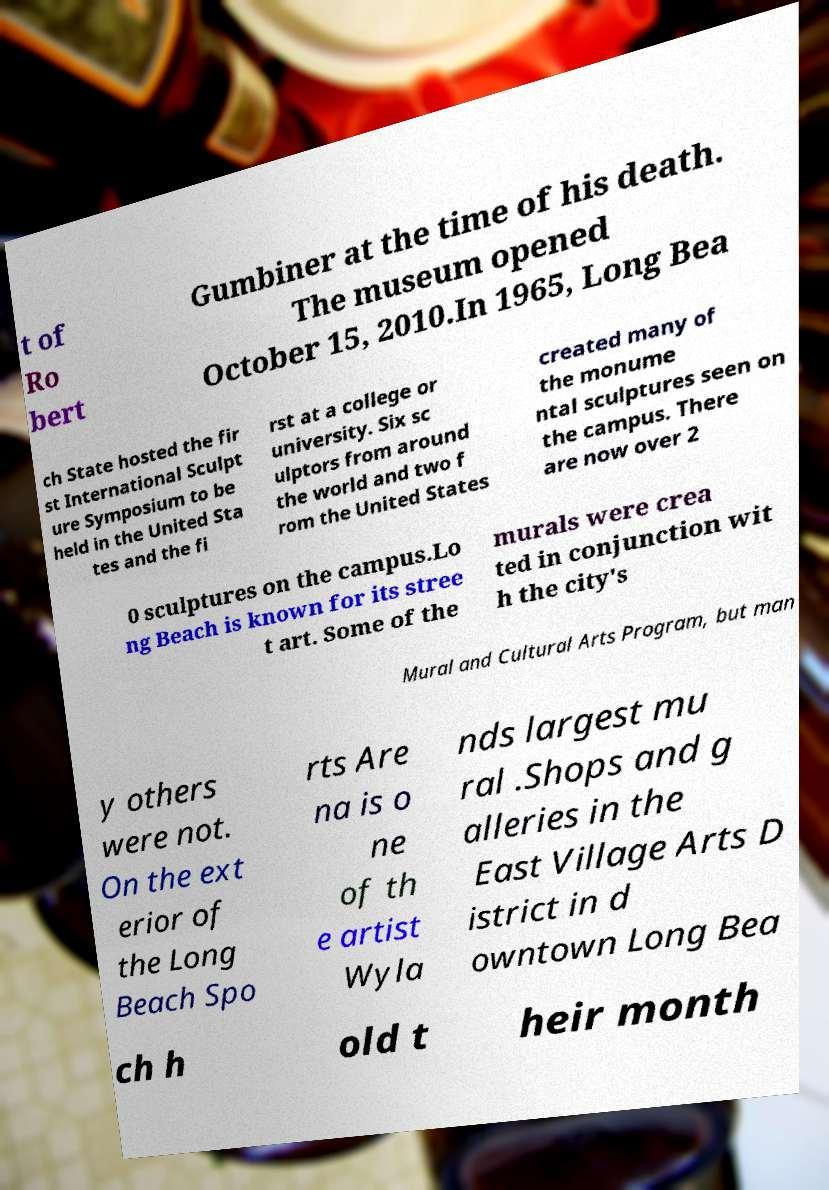Could you assist in decoding the text presented in this image and type it out clearly? t of Ro bert Gumbiner at the time of his death. The museum opened October 15, 2010.In 1965, Long Bea ch State hosted the fir st International Sculpt ure Symposium to be held in the United Sta tes and the fi rst at a college or university. Six sc ulptors from around the world and two f rom the United States created many of the monume ntal sculptures seen on the campus. There are now over 2 0 sculptures on the campus.Lo ng Beach is known for its stree t art. Some of the murals were crea ted in conjunction wit h the city's Mural and Cultural Arts Program, but man y others were not. On the ext erior of the Long Beach Spo rts Are na is o ne of th e artist Wyla nds largest mu ral .Shops and g alleries in the East Village Arts D istrict in d owntown Long Bea ch h old t heir month 